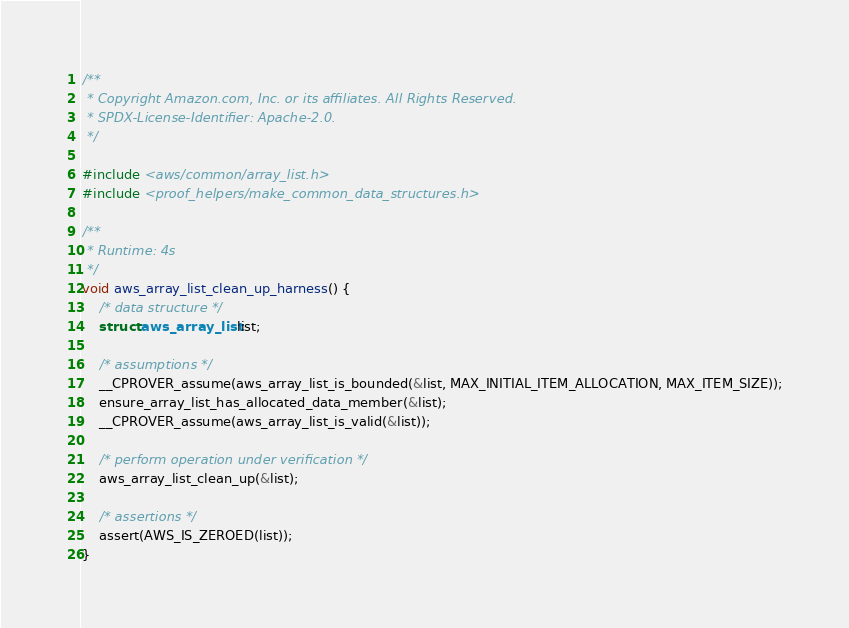Convert code to text. <code><loc_0><loc_0><loc_500><loc_500><_C_>/**
 * Copyright Amazon.com, Inc. or its affiliates. All Rights Reserved.
 * SPDX-License-Identifier: Apache-2.0.
 */

#include <aws/common/array_list.h>
#include <proof_helpers/make_common_data_structures.h>

/**
 * Runtime: 4s
 */
void aws_array_list_clean_up_harness() {
    /* data structure */
    struct aws_array_list list;

    /* assumptions */
    __CPROVER_assume(aws_array_list_is_bounded(&list, MAX_INITIAL_ITEM_ALLOCATION, MAX_ITEM_SIZE));
    ensure_array_list_has_allocated_data_member(&list);
    __CPROVER_assume(aws_array_list_is_valid(&list));

    /* perform operation under verification */
    aws_array_list_clean_up(&list);

    /* assertions */
    assert(AWS_IS_ZEROED(list));
}
</code> 